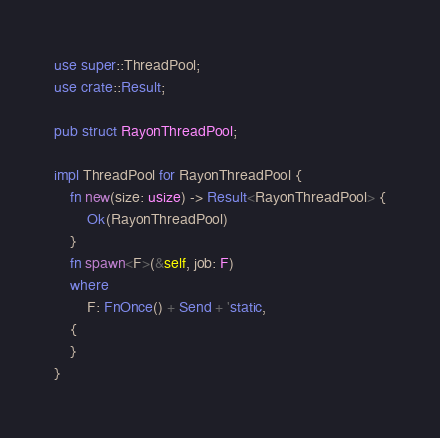<code> <loc_0><loc_0><loc_500><loc_500><_Rust_>use super::ThreadPool;
use crate::Result;

pub struct RayonThreadPool;

impl ThreadPool for RayonThreadPool {
    fn new(size: usize) -> Result<RayonThreadPool> {
        Ok(RayonThreadPool)
    }
    fn spawn<F>(&self, job: F)
    where
        F: FnOnce() + Send + 'static,
    {
    }
}
</code> 